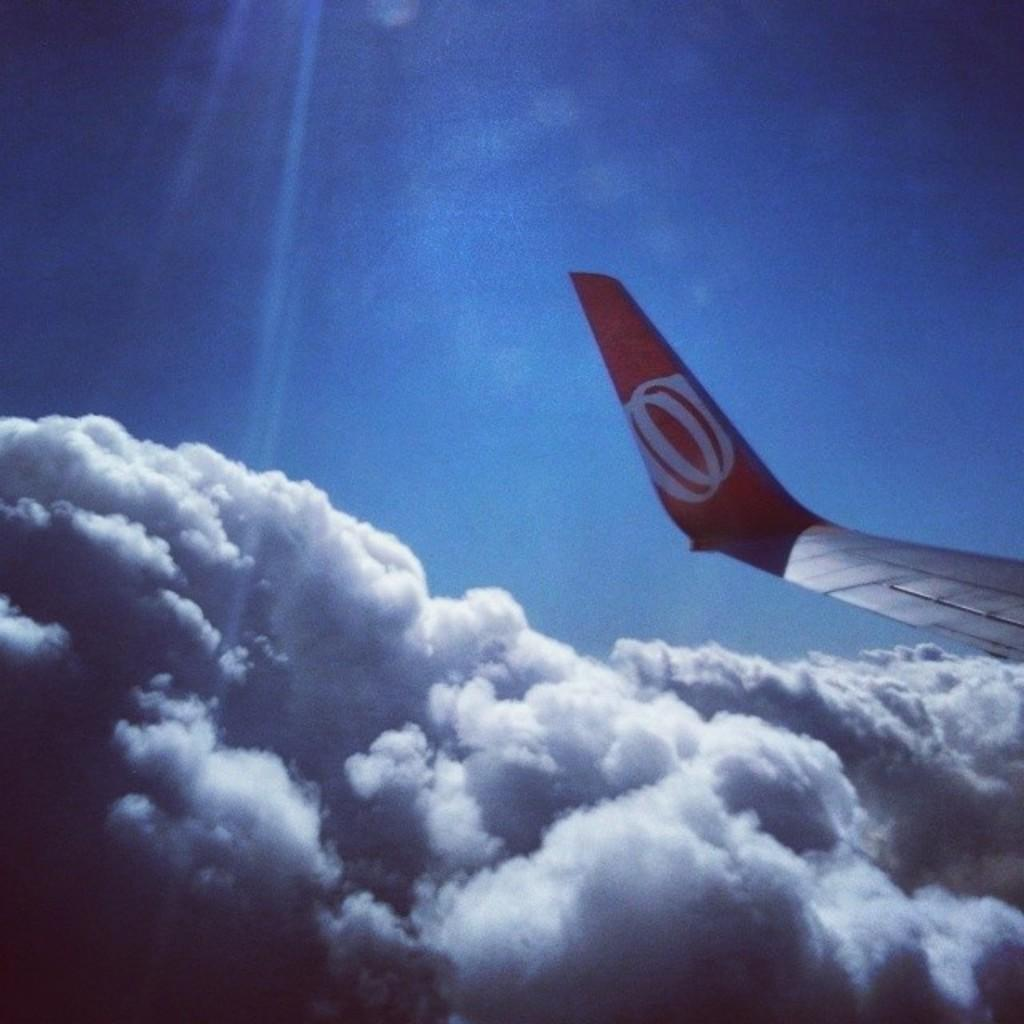What is located on the right side of the image? There is a tail of a flight on the right side of the image. What can be seen in the background of the image? Sky is visible in the background of the image. What is present in the sky? Clouds are present in the sky. What type of plastic plants can be seen growing near the tail of the flight in the image? There are no plastic plants present in the image. 